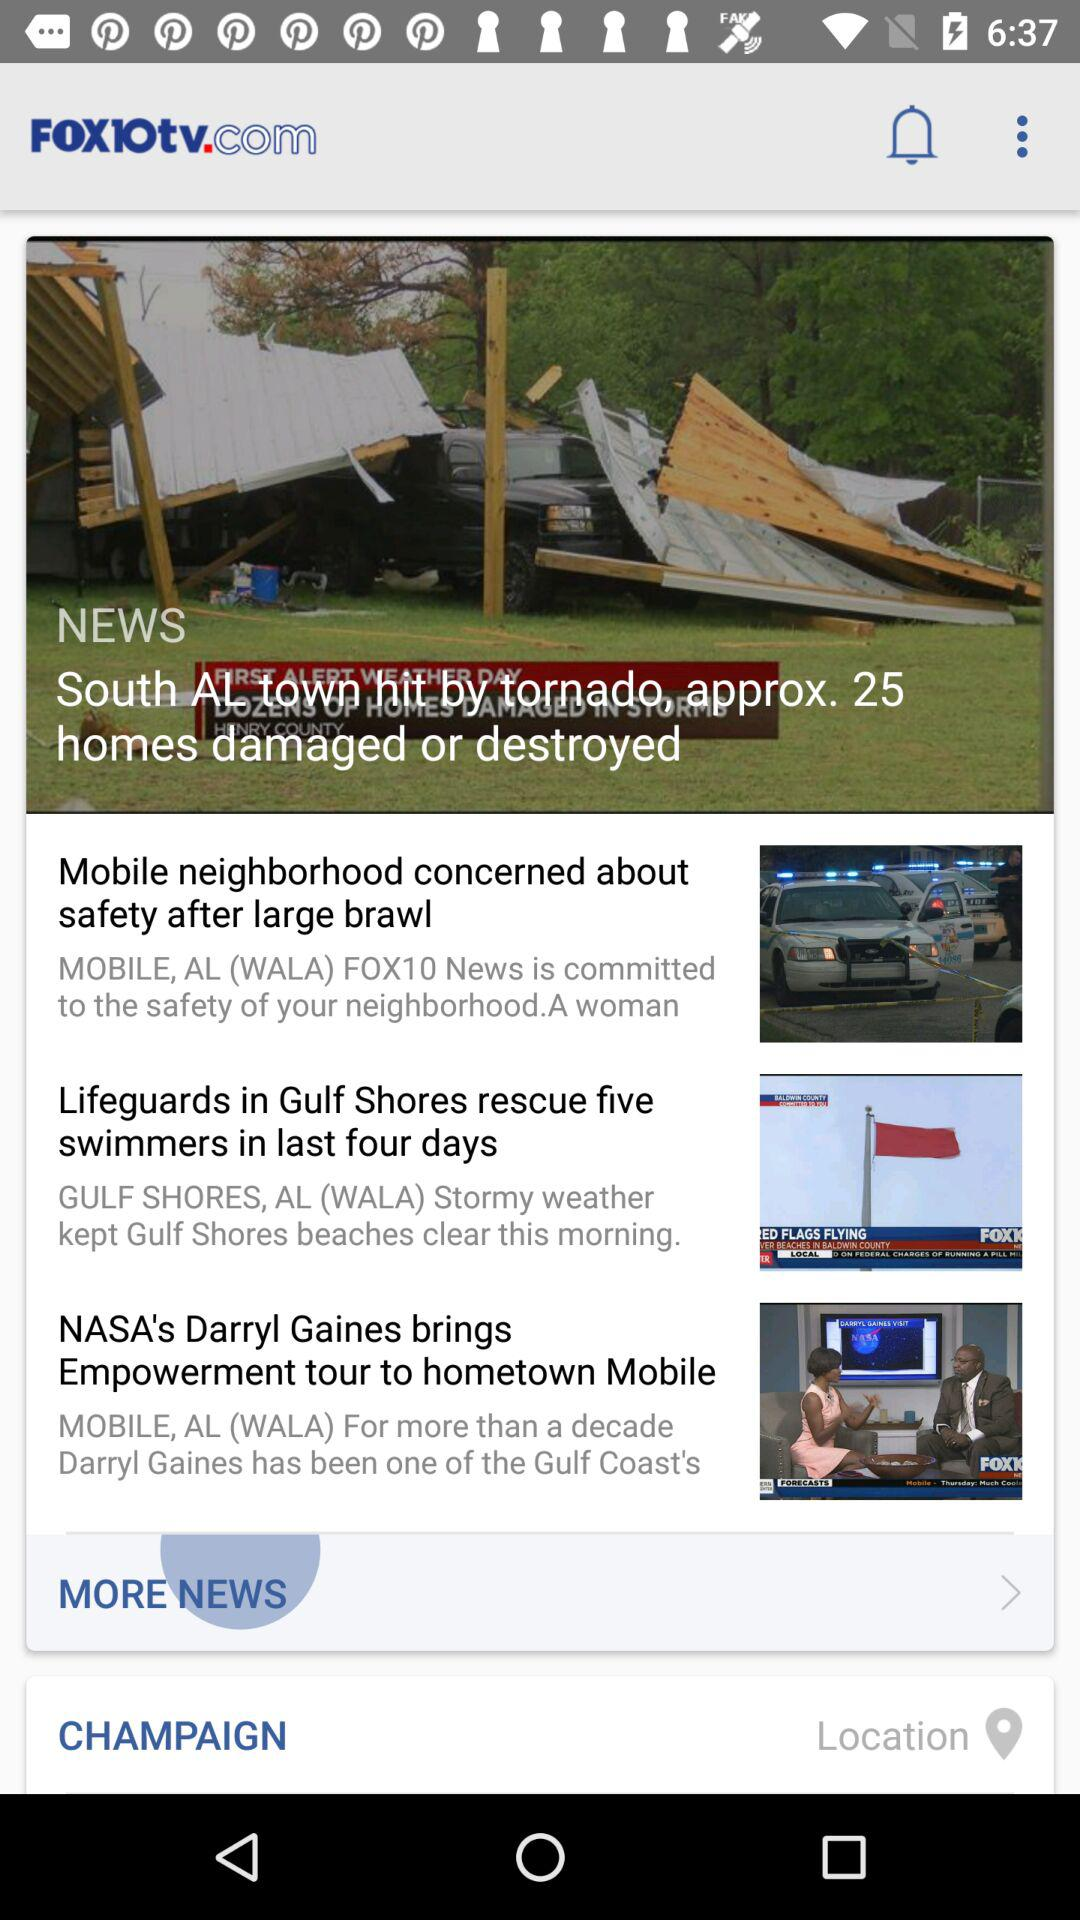What is the location? The location is Champaign. 